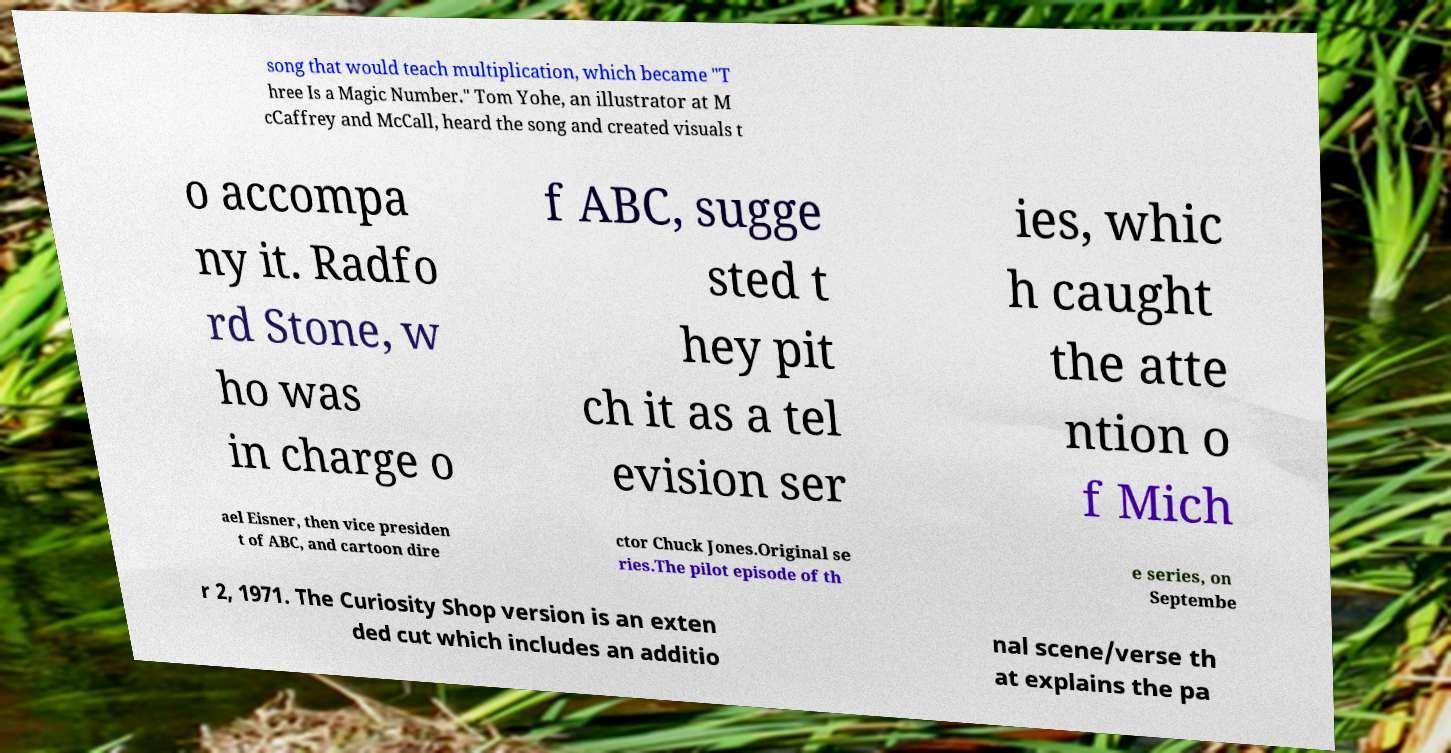For documentation purposes, I need the text within this image transcribed. Could you provide that? song that would teach multiplication, which became "T hree Is a Magic Number." Tom Yohe, an illustrator at M cCaffrey and McCall, heard the song and created visuals t o accompa ny it. Radfo rd Stone, w ho was in charge o f ABC, sugge sted t hey pit ch it as a tel evision ser ies, whic h caught the atte ntion o f Mich ael Eisner, then vice presiden t of ABC, and cartoon dire ctor Chuck Jones.Original se ries.The pilot episode of th e series, on Septembe r 2, 1971. The Curiosity Shop version is an exten ded cut which includes an additio nal scene/verse th at explains the pa 